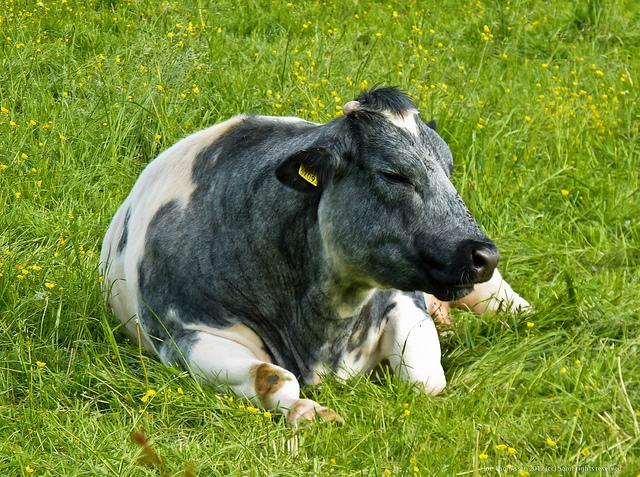Where on the cow's body is there a tag?
Quick response, please. Ear. In what position is the cow?
Keep it brief. Laying down. Is the bull looking away?
Be succinct. Yes. What is on the top of the animal's head?
Short answer required. Hair. 